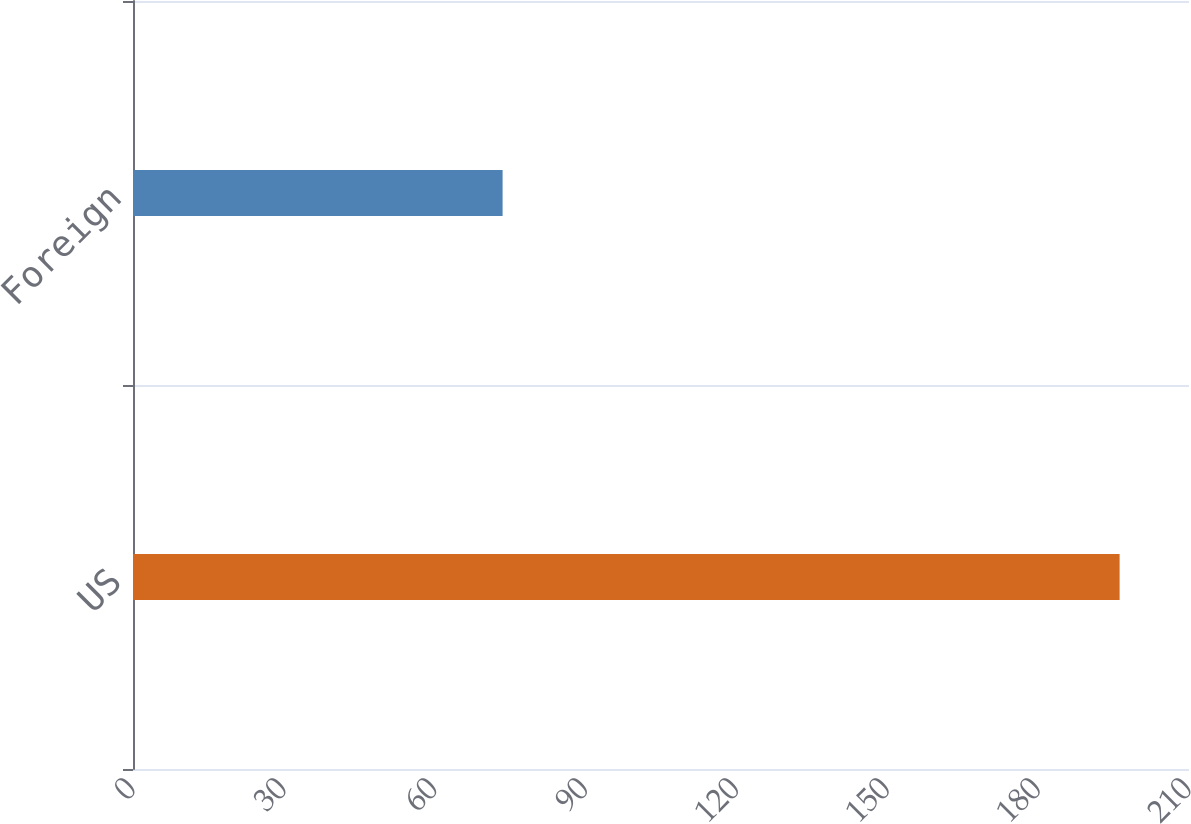Convert chart to OTSL. <chart><loc_0><loc_0><loc_500><loc_500><bar_chart><fcel>US<fcel>Foreign<nl><fcel>196.2<fcel>73.5<nl></chart> 